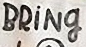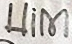What words are shown in these images in order, separated by a semicolon? BRİNg; Him 